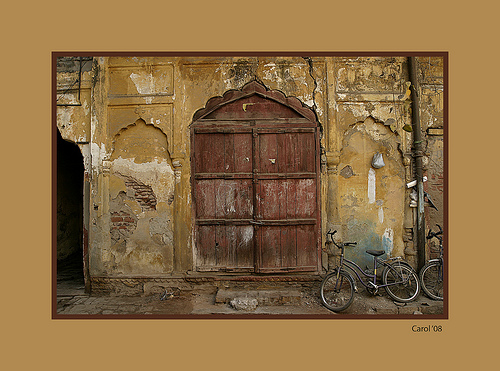What might be the historical significance of this building? The architectural style and the apparent age of the building suggest it could have been a significant commercial or residential structure in its prime. The ornate doorway and distressed walls might indicate a rich past, possibly dating back to a thriving period in the local history, now marked by time and neglect. How does the presence of the bicycle affect the perception of this space? The bicycle adds a layer of contemporary life to the scene, bridging the gap between the past and present. It suggests the space, despite its age and decay, continues to serve a purpose, blending historical aesthetics with current utility. 